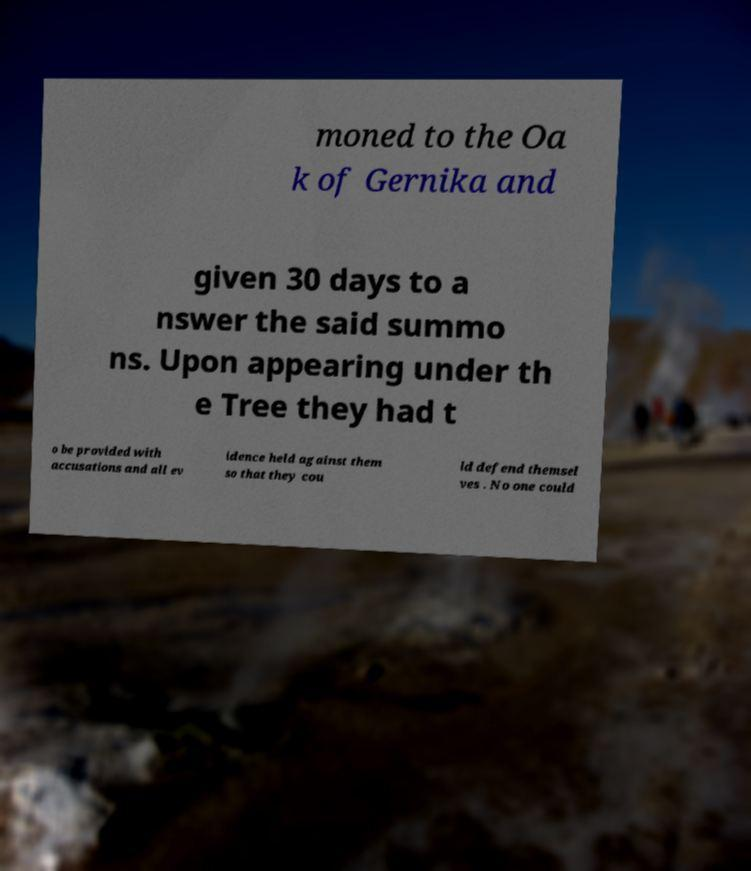Could you assist in decoding the text presented in this image and type it out clearly? moned to the Oa k of Gernika and given 30 days to a nswer the said summo ns. Upon appearing under th e Tree they had t o be provided with accusations and all ev idence held against them so that they cou ld defend themsel ves . No one could 